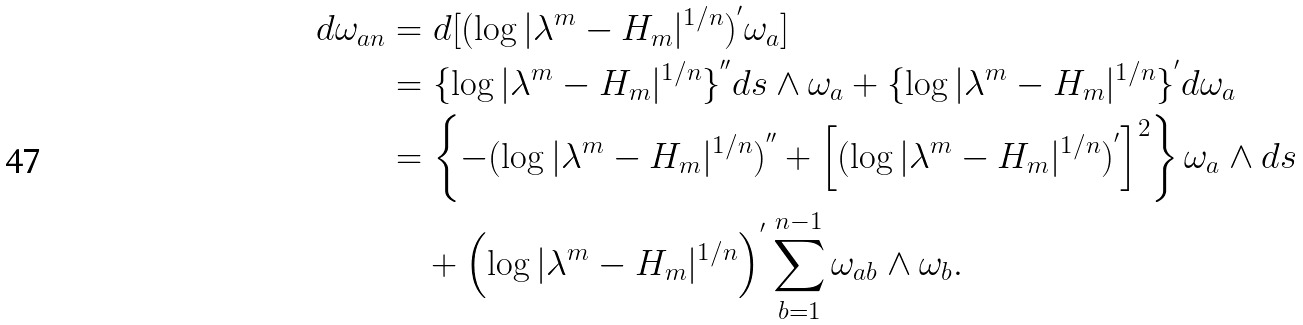<formula> <loc_0><loc_0><loc_500><loc_500>d \omega _ { a n } & = d [ ( \log | \lambda ^ { m } - H _ { m } | ^ { 1 / n } ) ^ { ^ { \prime } } \omega _ { a } ] \\ & = \{ \log | \lambda ^ { m } - H _ { m } | ^ { 1 / n } \} ^ { ^ { \prime \prime } } d s \wedge \omega _ { a } + \{ \log | \lambda ^ { m } - H _ { m } | ^ { 1 / n } \} ^ { ^ { \prime } } d \omega _ { a } \\ & = \left \{ - ( \log | \lambda ^ { m } - H _ { m } | ^ { 1 / n } ) ^ { ^ { \prime \prime } } + \left [ ( \log | \lambda ^ { m } - H _ { m } | ^ { 1 / n } ) ^ { ^ { \prime } } \right ] ^ { 2 } \right \} \omega _ { a } \wedge d s \\ & \quad + \left ( \log | \lambda ^ { m } - H _ { m } | ^ { 1 / n } \right ) ^ { ^ { \prime } } \sum _ { b = 1 } ^ { n - 1 } \omega _ { a b } \wedge \omega _ { b } .</formula> 